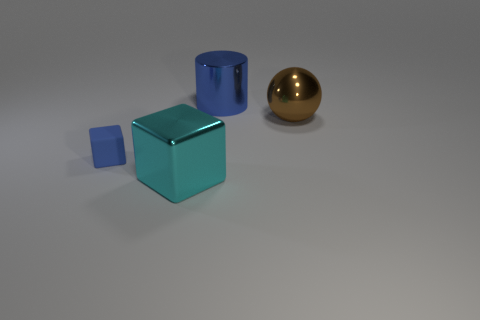There is a metallic cylinder; is its color the same as the cube behind the cyan thing?
Keep it short and to the point. Yes. Is the number of rubber objects greater than the number of tiny gray things?
Provide a succinct answer. Yes. There is another thing that is the same shape as the tiny object; what size is it?
Provide a succinct answer. Large. Do the tiny blue thing and the blue object to the right of the large shiny cube have the same material?
Your response must be concise. No. What number of things are cyan metallic things or blue cylinders?
Ensure brevity in your answer.  2. Does the blue thing that is on the left side of the big blue object have the same size as the cyan block that is in front of the brown thing?
Provide a short and direct response. No. How many cubes are either blue rubber objects or large metal things?
Give a very brief answer. 2. Are any matte cubes visible?
Your answer should be very brief. Yes. Is there anything else that has the same shape as the big blue shiny thing?
Ensure brevity in your answer.  No. Does the tiny cube have the same color as the metallic cylinder?
Make the answer very short. Yes. 